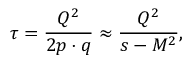Convert formula to latex. <formula><loc_0><loc_0><loc_500><loc_500>\tau = \frac { Q ^ { 2 } } { 2 p \cdot q } \approx \frac { Q ^ { 2 } } { s - M ^ { 2 } } ,</formula> 